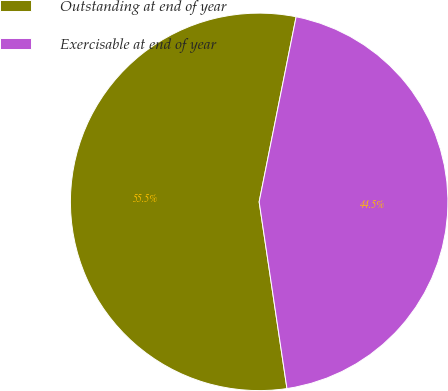Convert chart to OTSL. <chart><loc_0><loc_0><loc_500><loc_500><pie_chart><fcel>Outstanding at end of year<fcel>Exercisable at end of year<nl><fcel>55.49%<fcel>44.51%<nl></chart> 